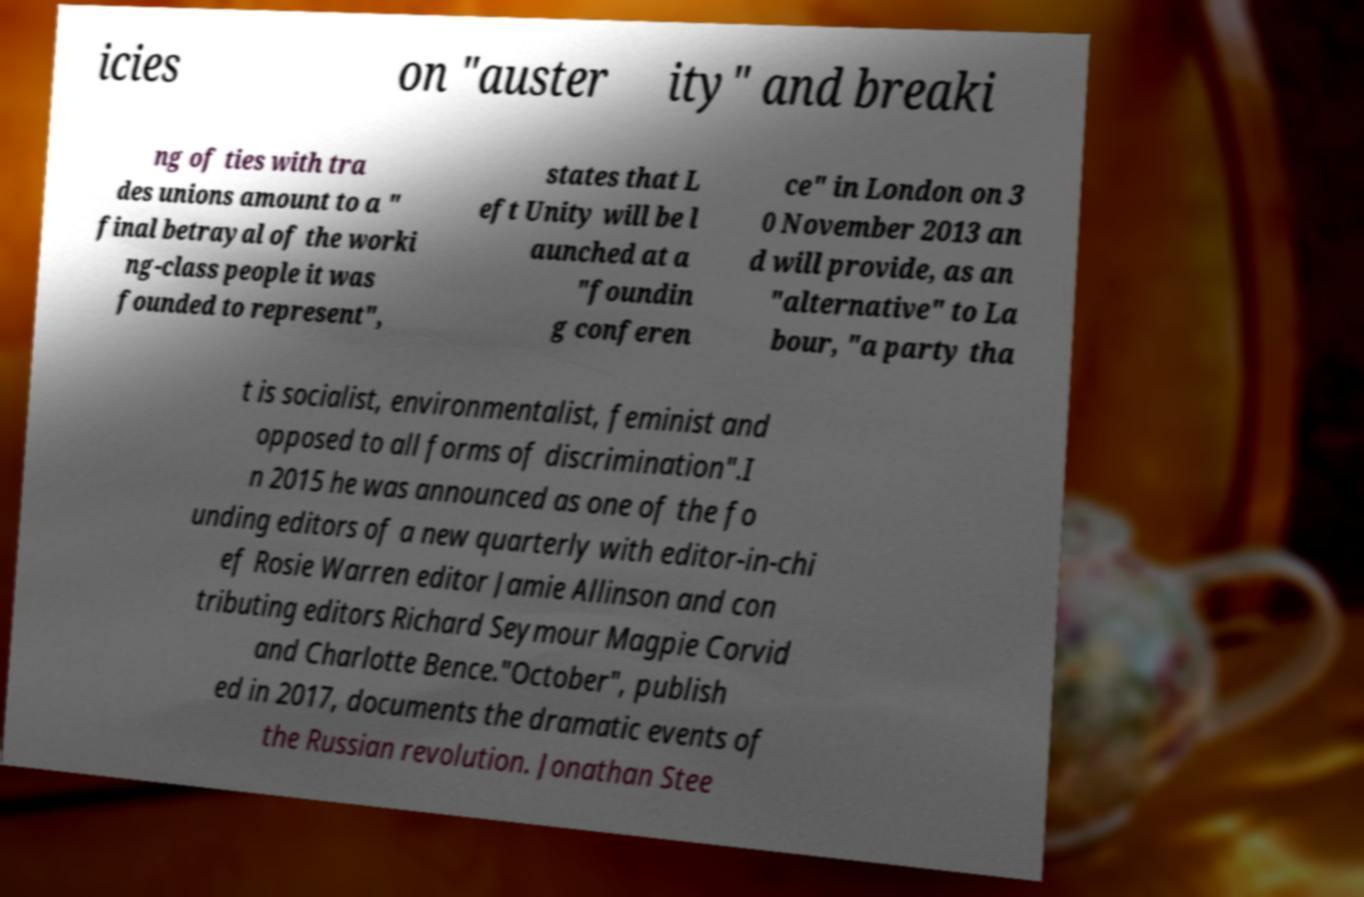Please identify and transcribe the text found in this image. icies on "auster ity" and breaki ng of ties with tra des unions amount to a " final betrayal of the worki ng-class people it was founded to represent", states that L eft Unity will be l aunched at a "foundin g conferen ce" in London on 3 0 November 2013 an d will provide, as an "alternative" to La bour, "a party tha t is socialist, environmentalist, feminist and opposed to all forms of discrimination".I n 2015 he was announced as one of the fo unding editors of a new quarterly with editor-in-chi ef Rosie Warren editor Jamie Allinson and con tributing editors Richard Seymour Magpie Corvid and Charlotte Bence."October", publish ed in 2017, documents the dramatic events of the Russian revolution. Jonathan Stee 